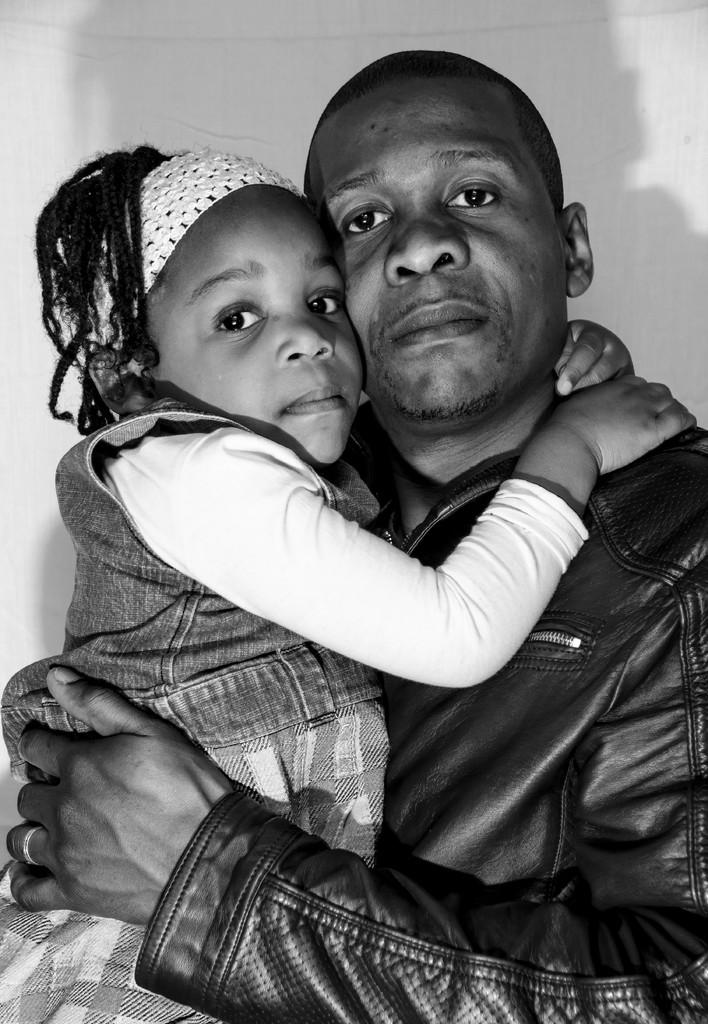What is the color scheme of the image? The image is black and white. Who is present in the image? There is a man in the image. What is the man wearing? The man is wearing a black leather jacket. What is the man doing in the image? The man is holding a little girl. What can be seen in the background of the image? There is a wall in the background of the image. What type of process is being carried out in the park in the image? There is no park present in the image, and no process is being carried out. 